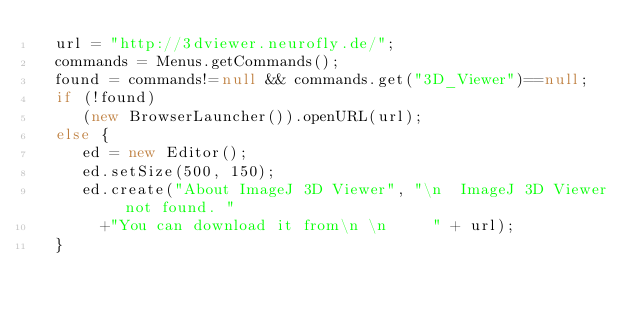Convert code to text. <code><loc_0><loc_0><loc_500><loc_500><_JavaScript_>  url = "http://3dviewer.neurofly.de/";
  commands = Menus.getCommands();
  found = commands!=null && commands.get("3D_Viewer")==null;
  if (!found)
     (new BrowserLauncher()).openURL(url);
  else {
     ed = new Editor();
     ed.setSize(500, 150);
     ed.create("About ImageJ 3D Viewer", "\n  ImageJ 3D Viewer not found. "
       +"You can download it from\n \n     " + url);
  }
</code> 